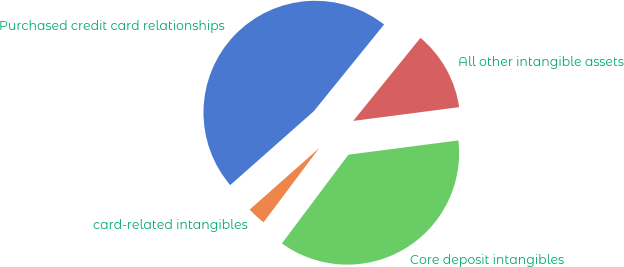Convert chart to OTSL. <chart><loc_0><loc_0><loc_500><loc_500><pie_chart><fcel>Purchased credit card relationships<fcel>card-related intangibles<fcel>Core deposit intangibles<fcel>All other intangible assets<nl><fcel>47.36%<fcel>3.24%<fcel>37.29%<fcel>12.11%<nl></chart> 